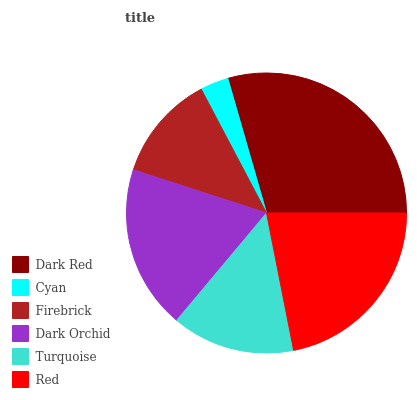Is Cyan the minimum?
Answer yes or no. Yes. Is Dark Red the maximum?
Answer yes or no. Yes. Is Firebrick the minimum?
Answer yes or no. No. Is Firebrick the maximum?
Answer yes or no. No. Is Firebrick greater than Cyan?
Answer yes or no. Yes. Is Cyan less than Firebrick?
Answer yes or no. Yes. Is Cyan greater than Firebrick?
Answer yes or no. No. Is Firebrick less than Cyan?
Answer yes or no. No. Is Dark Orchid the high median?
Answer yes or no. Yes. Is Turquoise the low median?
Answer yes or no. Yes. Is Red the high median?
Answer yes or no. No. Is Dark Orchid the low median?
Answer yes or no. No. 